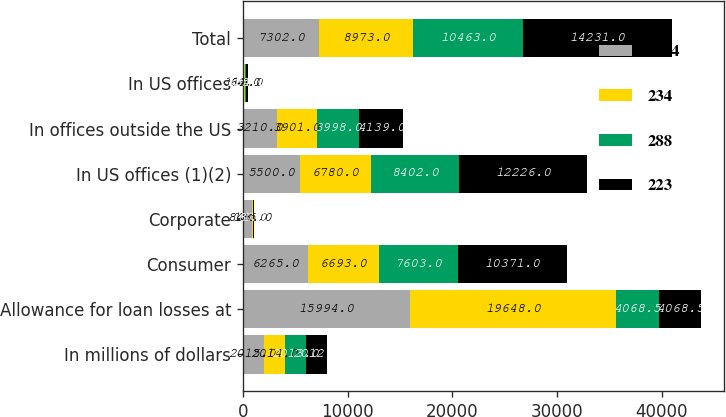Convert chart to OTSL. <chart><loc_0><loc_0><loc_500><loc_500><stacked_bar_chart><ecel><fcel>In millions of dollars<fcel>Allowance for loan losses at<fcel>Consumer<fcel>Corporate<fcel>In US offices (1)(2)<fcel>In offices outside the US<fcel>In US offices<fcel>Total<nl><fcel>1614<fcel>2015<fcel>15994<fcel>6265<fcel>843<fcel>5500<fcel>3210<fcel>112<fcel>7302<nl><fcel>234<fcel>2014<fcel>19648<fcel>6693<fcel>135<fcel>6780<fcel>3901<fcel>66<fcel>8973<nl><fcel>288<fcel>2013<fcel>4068.5<fcel>7603<fcel>1<fcel>8402<fcel>3998<fcel>125<fcel>10463<nl><fcel>223<fcel>2012<fcel>4068.5<fcel>10371<fcel>87<fcel>12226<fcel>4139<fcel>154<fcel>14231<nl></chart> 